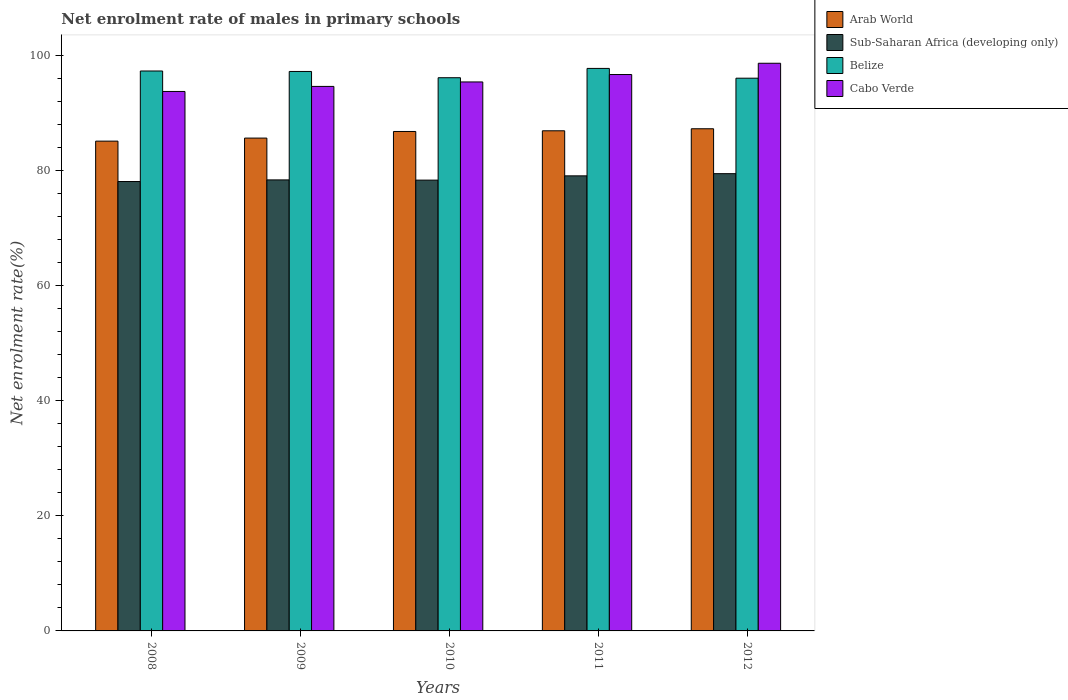Are the number of bars per tick equal to the number of legend labels?
Provide a succinct answer. Yes. Are the number of bars on each tick of the X-axis equal?
Offer a terse response. Yes. How many bars are there on the 4th tick from the left?
Offer a very short reply. 4. How many bars are there on the 5th tick from the right?
Provide a short and direct response. 4. What is the net enrolment rate of males in primary schools in Belize in 2010?
Ensure brevity in your answer.  96.17. Across all years, what is the maximum net enrolment rate of males in primary schools in Belize?
Ensure brevity in your answer.  97.79. Across all years, what is the minimum net enrolment rate of males in primary schools in Belize?
Make the answer very short. 96.09. What is the total net enrolment rate of males in primary schools in Cabo Verde in the graph?
Your response must be concise. 479.31. What is the difference between the net enrolment rate of males in primary schools in Sub-Saharan Africa (developing only) in 2008 and that in 2011?
Provide a succinct answer. -0.99. What is the difference between the net enrolment rate of males in primary schools in Cabo Verde in 2008 and the net enrolment rate of males in primary schools in Belize in 2009?
Offer a very short reply. -3.48. What is the average net enrolment rate of males in primary schools in Cabo Verde per year?
Offer a very short reply. 95.86. In the year 2012, what is the difference between the net enrolment rate of males in primary schools in Belize and net enrolment rate of males in primary schools in Sub-Saharan Africa (developing only)?
Your response must be concise. 16.6. What is the ratio of the net enrolment rate of males in primary schools in Belize in 2008 to that in 2010?
Provide a short and direct response. 1.01. Is the difference between the net enrolment rate of males in primary schools in Belize in 2009 and 2010 greater than the difference between the net enrolment rate of males in primary schools in Sub-Saharan Africa (developing only) in 2009 and 2010?
Give a very brief answer. Yes. What is the difference between the highest and the second highest net enrolment rate of males in primary schools in Arab World?
Your response must be concise. 0.35. What is the difference between the highest and the lowest net enrolment rate of males in primary schools in Belize?
Ensure brevity in your answer.  1.7. Is the sum of the net enrolment rate of males in primary schools in Cabo Verde in 2008 and 2011 greater than the maximum net enrolment rate of males in primary schools in Sub-Saharan Africa (developing only) across all years?
Provide a short and direct response. Yes. What does the 1st bar from the left in 2008 represents?
Offer a terse response. Arab World. What does the 4th bar from the right in 2012 represents?
Provide a short and direct response. Arab World. Is it the case that in every year, the sum of the net enrolment rate of males in primary schools in Belize and net enrolment rate of males in primary schools in Arab World is greater than the net enrolment rate of males in primary schools in Sub-Saharan Africa (developing only)?
Ensure brevity in your answer.  Yes. Are all the bars in the graph horizontal?
Your answer should be very brief. No. How many years are there in the graph?
Offer a very short reply. 5. What is the difference between two consecutive major ticks on the Y-axis?
Ensure brevity in your answer.  20. Does the graph contain any zero values?
Your answer should be compact. No. Does the graph contain grids?
Provide a succinct answer. No. How many legend labels are there?
Keep it short and to the point. 4. What is the title of the graph?
Provide a succinct answer. Net enrolment rate of males in primary schools. Does "Kazakhstan" appear as one of the legend labels in the graph?
Make the answer very short. No. What is the label or title of the Y-axis?
Your response must be concise. Net enrolment rate(%). What is the Net enrolment rate(%) in Arab World in 2008?
Offer a terse response. 85.15. What is the Net enrolment rate(%) in Sub-Saharan Africa (developing only) in 2008?
Provide a short and direct response. 78.13. What is the Net enrolment rate(%) in Belize in 2008?
Your response must be concise. 97.34. What is the Net enrolment rate(%) of Cabo Verde in 2008?
Ensure brevity in your answer.  93.79. What is the Net enrolment rate(%) of Arab World in 2009?
Offer a terse response. 85.68. What is the Net enrolment rate(%) in Sub-Saharan Africa (developing only) in 2009?
Give a very brief answer. 78.41. What is the Net enrolment rate(%) in Belize in 2009?
Provide a succinct answer. 97.26. What is the Net enrolment rate(%) in Cabo Verde in 2009?
Your answer should be very brief. 94.66. What is the Net enrolment rate(%) of Arab World in 2010?
Offer a terse response. 86.83. What is the Net enrolment rate(%) of Sub-Saharan Africa (developing only) in 2010?
Your answer should be very brief. 78.37. What is the Net enrolment rate(%) of Belize in 2010?
Your response must be concise. 96.17. What is the Net enrolment rate(%) of Cabo Verde in 2010?
Provide a short and direct response. 95.44. What is the Net enrolment rate(%) in Arab World in 2011?
Keep it short and to the point. 86.95. What is the Net enrolment rate(%) in Sub-Saharan Africa (developing only) in 2011?
Your response must be concise. 79.12. What is the Net enrolment rate(%) in Belize in 2011?
Your response must be concise. 97.79. What is the Net enrolment rate(%) of Cabo Verde in 2011?
Make the answer very short. 96.73. What is the Net enrolment rate(%) in Arab World in 2012?
Provide a short and direct response. 87.3. What is the Net enrolment rate(%) in Sub-Saharan Africa (developing only) in 2012?
Your answer should be very brief. 79.49. What is the Net enrolment rate(%) of Belize in 2012?
Offer a terse response. 96.09. What is the Net enrolment rate(%) in Cabo Verde in 2012?
Provide a short and direct response. 98.69. Across all years, what is the maximum Net enrolment rate(%) of Arab World?
Provide a short and direct response. 87.3. Across all years, what is the maximum Net enrolment rate(%) in Sub-Saharan Africa (developing only)?
Make the answer very short. 79.49. Across all years, what is the maximum Net enrolment rate(%) of Belize?
Your response must be concise. 97.79. Across all years, what is the maximum Net enrolment rate(%) of Cabo Verde?
Give a very brief answer. 98.69. Across all years, what is the minimum Net enrolment rate(%) of Arab World?
Make the answer very short. 85.15. Across all years, what is the minimum Net enrolment rate(%) in Sub-Saharan Africa (developing only)?
Make the answer very short. 78.13. Across all years, what is the minimum Net enrolment rate(%) in Belize?
Provide a succinct answer. 96.09. Across all years, what is the minimum Net enrolment rate(%) of Cabo Verde?
Provide a succinct answer. 93.79. What is the total Net enrolment rate(%) of Arab World in the graph?
Offer a terse response. 431.91. What is the total Net enrolment rate(%) of Sub-Saharan Africa (developing only) in the graph?
Offer a terse response. 393.52. What is the total Net enrolment rate(%) of Belize in the graph?
Offer a very short reply. 484.67. What is the total Net enrolment rate(%) in Cabo Verde in the graph?
Give a very brief answer. 479.31. What is the difference between the Net enrolment rate(%) of Arab World in 2008 and that in 2009?
Offer a very short reply. -0.53. What is the difference between the Net enrolment rate(%) of Sub-Saharan Africa (developing only) in 2008 and that in 2009?
Make the answer very short. -0.28. What is the difference between the Net enrolment rate(%) of Belize in 2008 and that in 2009?
Your answer should be compact. 0.08. What is the difference between the Net enrolment rate(%) of Cabo Verde in 2008 and that in 2009?
Ensure brevity in your answer.  -0.88. What is the difference between the Net enrolment rate(%) of Arab World in 2008 and that in 2010?
Your response must be concise. -1.68. What is the difference between the Net enrolment rate(%) in Sub-Saharan Africa (developing only) in 2008 and that in 2010?
Provide a succinct answer. -0.24. What is the difference between the Net enrolment rate(%) in Belize in 2008 and that in 2010?
Provide a succinct answer. 1.17. What is the difference between the Net enrolment rate(%) in Cabo Verde in 2008 and that in 2010?
Ensure brevity in your answer.  -1.66. What is the difference between the Net enrolment rate(%) in Arab World in 2008 and that in 2011?
Make the answer very short. -1.8. What is the difference between the Net enrolment rate(%) in Sub-Saharan Africa (developing only) in 2008 and that in 2011?
Offer a terse response. -0.99. What is the difference between the Net enrolment rate(%) of Belize in 2008 and that in 2011?
Your response must be concise. -0.45. What is the difference between the Net enrolment rate(%) of Cabo Verde in 2008 and that in 2011?
Your answer should be very brief. -2.94. What is the difference between the Net enrolment rate(%) in Arab World in 2008 and that in 2012?
Give a very brief answer. -2.15. What is the difference between the Net enrolment rate(%) in Sub-Saharan Africa (developing only) in 2008 and that in 2012?
Provide a succinct answer. -1.37. What is the difference between the Net enrolment rate(%) of Belize in 2008 and that in 2012?
Offer a terse response. 1.25. What is the difference between the Net enrolment rate(%) in Cabo Verde in 2008 and that in 2012?
Offer a very short reply. -4.9. What is the difference between the Net enrolment rate(%) in Arab World in 2009 and that in 2010?
Provide a short and direct response. -1.15. What is the difference between the Net enrolment rate(%) in Sub-Saharan Africa (developing only) in 2009 and that in 2010?
Your answer should be very brief. 0.04. What is the difference between the Net enrolment rate(%) of Belize in 2009 and that in 2010?
Ensure brevity in your answer.  1.09. What is the difference between the Net enrolment rate(%) of Cabo Verde in 2009 and that in 2010?
Your response must be concise. -0.78. What is the difference between the Net enrolment rate(%) in Arab World in 2009 and that in 2011?
Give a very brief answer. -1.27. What is the difference between the Net enrolment rate(%) of Sub-Saharan Africa (developing only) in 2009 and that in 2011?
Offer a terse response. -0.7. What is the difference between the Net enrolment rate(%) of Belize in 2009 and that in 2011?
Provide a succinct answer. -0.53. What is the difference between the Net enrolment rate(%) in Cabo Verde in 2009 and that in 2011?
Ensure brevity in your answer.  -2.07. What is the difference between the Net enrolment rate(%) in Arab World in 2009 and that in 2012?
Keep it short and to the point. -1.62. What is the difference between the Net enrolment rate(%) in Sub-Saharan Africa (developing only) in 2009 and that in 2012?
Keep it short and to the point. -1.08. What is the difference between the Net enrolment rate(%) in Belize in 2009 and that in 2012?
Make the answer very short. 1.17. What is the difference between the Net enrolment rate(%) in Cabo Verde in 2009 and that in 2012?
Keep it short and to the point. -4.02. What is the difference between the Net enrolment rate(%) in Arab World in 2010 and that in 2011?
Your answer should be very brief. -0.12. What is the difference between the Net enrolment rate(%) of Sub-Saharan Africa (developing only) in 2010 and that in 2011?
Your answer should be compact. -0.74. What is the difference between the Net enrolment rate(%) in Belize in 2010 and that in 2011?
Provide a short and direct response. -1.62. What is the difference between the Net enrolment rate(%) of Cabo Verde in 2010 and that in 2011?
Offer a very short reply. -1.29. What is the difference between the Net enrolment rate(%) in Arab World in 2010 and that in 2012?
Your response must be concise. -0.47. What is the difference between the Net enrolment rate(%) of Sub-Saharan Africa (developing only) in 2010 and that in 2012?
Make the answer very short. -1.12. What is the difference between the Net enrolment rate(%) in Belize in 2010 and that in 2012?
Make the answer very short. 0.08. What is the difference between the Net enrolment rate(%) in Cabo Verde in 2010 and that in 2012?
Provide a succinct answer. -3.25. What is the difference between the Net enrolment rate(%) of Arab World in 2011 and that in 2012?
Your response must be concise. -0.35. What is the difference between the Net enrolment rate(%) of Sub-Saharan Africa (developing only) in 2011 and that in 2012?
Your response must be concise. -0.38. What is the difference between the Net enrolment rate(%) of Belize in 2011 and that in 2012?
Your response must be concise. 1.7. What is the difference between the Net enrolment rate(%) of Cabo Verde in 2011 and that in 2012?
Offer a very short reply. -1.96. What is the difference between the Net enrolment rate(%) in Arab World in 2008 and the Net enrolment rate(%) in Sub-Saharan Africa (developing only) in 2009?
Give a very brief answer. 6.74. What is the difference between the Net enrolment rate(%) of Arab World in 2008 and the Net enrolment rate(%) of Belize in 2009?
Your answer should be compact. -12.11. What is the difference between the Net enrolment rate(%) of Arab World in 2008 and the Net enrolment rate(%) of Cabo Verde in 2009?
Your answer should be very brief. -9.51. What is the difference between the Net enrolment rate(%) of Sub-Saharan Africa (developing only) in 2008 and the Net enrolment rate(%) of Belize in 2009?
Provide a succinct answer. -19.14. What is the difference between the Net enrolment rate(%) in Sub-Saharan Africa (developing only) in 2008 and the Net enrolment rate(%) in Cabo Verde in 2009?
Your answer should be very brief. -16.54. What is the difference between the Net enrolment rate(%) in Belize in 2008 and the Net enrolment rate(%) in Cabo Verde in 2009?
Make the answer very short. 2.68. What is the difference between the Net enrolment rate(%) of Arab World in 2008 and the Net enrolment rate(%) of Sub-Saharan Africa (developing only) in 2010?
Provide a short and direct response. 6.78. What is the difference between the Net enrolment rate(%) in Arab World in 2008 and the Net enrolment rate(%) in Belize in 2010?
Ensure brevity in your answer.  -11.02. What is the difference between the Net enrolment rate(%) of Arab World in 2008 and the Net enrolment rate(%) of Cabo Verde in 2010?
Provide a succinct answer. -10.29. What is the difference between the Net enrolment rate(%) of Sub-Saharan Africa (developing only) in 2008 and the Net enrolment rate(%) of Belize in 2010?
Your answer should be very brief. -18.05. What is the difference between the Net enrolment rate(%) in Sub-Saharan Africa (developing only) in 2008 and the Net enrolment rate(%) in Cabo Verde in 2010?
Provide a short and direct response. -17.31. What is the difference between the Net enrolment rate(%) of Belize in 2008 and the Net enrolment rate(%) of Cabo Verde in 2010?
Ensure brevity in your answer.  1.9. What is the difference between the Net enrolment rate(%) of Arab World in 2008 and the Net enrolment rate(%) of Sub-Saharan Africa (developing only) in 2011?
Make the answer very short. 6.04. What is the difference between the Net enrolment rate(%) of Arab World in 2008 and the Net enrolment rate(%) of Belize in 2011?
Offer a terse response. -12.64. What is the difference between the Net enrolment rate(%) of Arab World in 2008 and the Net enrolment rate(%) of Cabo Verde in 2011?
Your answer should be compact. -11.58. What is the difference between the Net enrolment rate(%) in Sub-Saharan Africa (developing only) in 2008 and the Net enrolment rate(%) in Belize in 2011?
Give a very brief answer. -19.67. What is the difference between the Net enrolment rate(%) in Sub-Saharan Africa (developing only) in 2008 and the Net enrolment rate(%) in Cabo Verde in 2011?
Keep it short and to the point. -18.6. What is the difference between the Net enrolment rate(%) in Belize in 2008 and the Net enrolment rate(%) in Cabo Verde in 2011?
Keep it short and to the point. 0.61. What is the difference between the Net enrolment rate(%) of Arab World in 2008 and the Net enrolment rate(%) of Sub-Saharan Africa (developing only) in 2012?
Your answer should be compact. 5.66. What is the difference between the Net enrolment rate(%) of Arab World in 2008 and the Net enrolment rate(%) of Belize in 2012?
Ensure brevity in your answer.  -10.94. What is the difference between the Net enrolment rate(%) of Arab World in 2008 and the Net enrolment rate(%) of Cabo Verde in 2012?
Your answer should be compact. -13.54. What is the difference between the Net enrolment rate(%) in Sub-Saharan Africa (developing only) in 2008 and the Net enrolment rate(%) in Belize in 2012?
Offer a terse response. -17.97. What is the difference between the Net enrolment rate(%) in Sub-Saharan Africa (developing only) in 2008 and the Net enrolment rate(%) in Cabo Verde in 2012?
Your answer should be compact. -20.56. What is the difference between the Net enrolment rate(%) of Belize in 2008 and the Net enrolment rate(%) of Cabo Verde in 2012?
Your response must be concise. -1.35. What is the difference between the Net enrolment rate(%) in Arab World in 2009 and the Net enrolment rate(%) in Sub-Saharan Africa (developing only) in 2010?
Your answer should be compact. 7.31. What is the difference between the Net enrolment rate(%) of Arab World in 2009 and the Net enrolment rate(%) of Belize in 2010?
Provide a succinct answer. -10.49. What is the difference between the Net enrolment rate(%) of Arab World in 2009 and the Net enrolment rate(%) of Cabo Verde in 2010?
Offer a terse response. -9.76. What is the difference between the Net enrolment rate(%) of Sub-Saharan Africa (developing only) in 2009 and the Net enrolment rate(%) of Belize in 2010?
Your response must be concise. -17.76. What is the difference between the Net enrolment rate(%) of Sub-Saharan Africa (developing only) in 2009 and the Net enrolment rate(%) of Cabo Verde in 2010?
Offer a terse response. -17.03. What is the difference between the Net enrolment rate(%) in Belize in 2009 and the Net enrolment rate(%) in Cabo Verde in 2010?
Make the answer very short. 1.82. What is the difference between the Net enrolment rate(%) in Arab World in 2009 and the Net enrolment rate(%) in Sub-Saharan Africa (developing only) in 2011?
Provide a succinct answer. 6.57. What is the difference between the Net enrolment rate(%) in Arab World in 2009 and the Net enrolment rate(%) in Belize in 2011?
Your answer should be compact. -12.11. What is the difference between the Net enrolment rate(%) in Arab World in 2009 and the Net enrolment rate(%) in Cabo Verde in 2011?
Offer a very short reply. -11.05. What is the difference between the Net enrolment rate(%) of Sub-Saharan Africa (developing only) in 2009 and the Net enrolment rate(%) of Belize in 2011?
Keep it short and to the point. -19.38. What is the difference between the Net enrolment rate(%) in Sub-Saharan Africa (developing only) in 2009 and the Net enrolment rate(%) in Cabo Verde in 2011?
Provide a short and direct response. -18.32. What is the difference between the Net enrolment rate(%) in Belize in 2009 and the Net enrolment rate(%) in Cabo Verde in 2011?
Offer a terse response. 0.53. What is the difference between the Net enrolment rate(%) in Arab World in 2009 and the Net enrolment rate(%) in Sub-Saharan Africa (developing only) in 2012?
Keep it short and to the point. 6.19. What is the difference between the Net enrolment rate(%) of Arab World in 2009 and the Net enrolment rate(%) of Belize in 2012?
Provide a succinct answer. -10.41. What is the difference between the Net enrolment rate(%) in Arab World in 2009 and the Net enrolment rate(%) in Cabo Verde in 2012?
Offer a terse response. -13.01. What is the difference between the Net enrolment rate(%) in Sub-Saharan Africa (developing only) in 2009 and the Net enrolment rate(%) in Belize in 2012?
Keep it short and to the point. -17.68. What is the difference between the Net enrolment rate(%) of Sub-Saharan Africa (developing only) in 2009 and the Net enrolment rate(%) of Cabo Verde in 2012?
Provide a short and direct response. -20.28. What is the difference between the Net enrolment rate(%) in Belize in 2009 and the Net enrolment rate(%) in Cabo Verde in 2012?
Your answer should be very brief. -1.43. What is the difference between the Net enrolment rate(%) in Arab World in 2010 and the Net enrolment rate(%) in Sub-Saharan Africa (developing only) in 2011?
Make the answer very short. 7.71. What is the difference between the Net enrolment rate(%) of Arab World in 2010 and the Net enrolment rate(%) of Belize in 2011?
Your answer should be compact. -10.96. What is the difference between the Net enrolment rate(%) of Arab World in 2010 and the Net enrolment rate(%) of Cabo Verde in 2011?
Ensure brevity in your answer.  -9.9. What is the difference between the Net enrolment rate(%) of Sub-Saharan Africa (developing only) in 2010 and the Net enrolment rate(%) of Belize in 2011?
Keep it short and to the point. -19.42. What is the difference between the Net enrolment rate(%) of Sub-Saharan Africa (developing only) in 2010 and the Net enrolment rate(%) of Cabo Verde in 2011?
Your response must be concise. -18.36. What is the difference between the Net enrolment rate(%) of Belize in 2010 and the Net enrolment rate(%) of Cabo Verde in 2011?
Your response must be concise. -0.56. What is the difference between the Net enrolment rate(%) in Arab World in 2010 and the Net enrolment rate(%) in Sub-Saharan Africa (developing only) in 2012?
Keep it short and to the point. 7.34. What is the difference between the Net enrolment rate(%) in Arab World in 2010 and the Net enrolment rate(%) in Belize in 2012?
Offer a very short reply. -9.26. What is the difference between the Net enrolment rate(%) in Arab World in 2010 and the Net enrolment rate(%) in Cabo Verde in 2012?
Ensure brevity in your answer.  -11.86. What is the difference between the Net enrolment rate(%) in Sub-Saharan Africa (developing only) in 2010 and the Net enrolment rate(%) in Belize in 2012?
Your answer should be compact. -17.72. What is the difference between the Net enrolment rate(%) of Sub-Saharan Africa (developing only) in 2010 and the Net enrolment rate(%) of Cabo Verde in 2012?
Make the answer very short. -20.32. What is the difference between the Net enrolment rate(%) in Belize in 2010 and the Net enrolment rate(%) in Cabo Verde in 2012?
Your response must be concise. -2.52. What is the difference between the Net enrolment rate(%) of Arab World in 2011 and the Net enrolment rate(%) of Sub-Saharan Africa (developing only) in 2012?
Your response must be concise. 7.46. What is the difference between the Net enrolment rate(%) in Arab World in 2011 and the Net enrolment rate(%) in Belize in 2012?
Your response must be concise. -9.14. What is the difference between the Net enrolment rate(%) in Arab World in 2011 and the Net enrolment rate(%) in Cabo Verde in 2012?
Give a very brief answer. -11.74. What is the difference between the Net enrolment rate(%) of Sub-Saharan Africa (developing only) in 2011 and the Net enrolment rate(%) of Belize in 2012?
Provide a short and direct response. -16.98. What is the difference between the Net enrolment rate(%) in Sub-Saharan Africa (developing only) in 2011 and the Net enrolment rate(%) in Cabo Verde in 2012?
Provide a short and direct response. -19.57. What is the difference between the Net enrolment rate(%) of Belize in 2011 and the Net enrolment rate(%) of Cabo Verde in 2012?
Provide a short and direct response. -0.9. What is the average Net enrolment rate(%) of Arab World per year?
Provide a short and direct response. 86.38. What is the average Net enrolment rate(%) of Sub-Saharan Africa (developing only) per year?
Make the answer very short. 78.7. What is the average Net enrolment rate(%) in Belize per year?
Offer a very short reply. 96.93. What is the average Net enrolment rate(%) in Cabo Verde per year?
Make the answer very short. 95.86. In the year 2008, what is the difference between the Net enrolment rate(%) in Arab World and Net enrolment rate(%) in Sub-Saharan Africa (developing only)?
Offer a very short reply. 7.02. In the year 2008, what is the difference between the Net enrolment rate(%) in Arab World and Net enrolment rate(%) in Belize?
Make the answer very short. -12.19. In the year 2008, what is the difference between the Net enrolment rate(%) in Arab World and Net enrolment rate(%) in Cabo Verde?
Provide a short and direct response. -8.63. In the year 2008, what is the difference between the Net enrolment rate(%) of Sub-Saharan Africa (developing only) and Net enrolment rate(%) of Belize?
Provide a succinct answer. -19.22. In the year 2008, what is the difference between the Net enrolment rate(%) in Sub-Saharan Africa (developing only) and Net enrolment rate(%) in Cabo Verde?
Offer a very short reply. -15.66. In the year 2008, what is the difference between the Net enrolment rate(%) of Belize and Net enrolment rate(%) of Cabo Verde?
Keep it short and to the point. 3.56. In the year 2009, what is the difference between the Net enrolment rate(%) of Arab World and Net enrolment rate(%) of Sub-Saharan Africa (developing only)?
Your answer should be compact. 7.27. In the year 2009, what is the difference between the Net enrolment rate(%) in Arab World and Net enrolment rate(%) in Belize?
Offer a terse response. -11.58. In the year 2009, what is the difference between the Net enrolment rate(%) in Arab World and Net enrolment rate(%) in Cabo Verde?
Provide a succinct answer. -8.98. In the year 2009, what is the difference between the Net enrolment rate(%) in Sub-Saharan Africa (developing only) and Net enrolment rate(%) in Belize?
Make the answer very short. -18.85. In the year 2009, what is the difference between the Net enrolment rate(%) of Sub-Saharan Africa (developing only) and Net enrolment rate(%) of Cabo Verde?
Make the answer very short. -16.25. In the year 2009, what is the difference between the Net enrolment rate(%) in Belize and Net enrolment rate(%) in Cabo Verde?
Your response must be concise. 2.6. In the year 2010, what is the difference between the Net enrolment rate(%) in Arab World and Net enrolment rate(%) in Sub-Saharan Africa (developing only)?
Keep it short and to the point. 8.46. In the year 2010, what is the difference between the Net enrolment rate(%) in Arab World and Net enrolment rate(%) in Belize?
Provide a short and direct response. -9.34. In the year 2010, what is the difference between the Net enrolment rate(%) in Arab World and Net enrolment rate(%) in Cabo Verde?
Provide a succinct answer. -8.61. In the year 2010, what is the difference between the Net enrolment rate(%) in Sub-Saharan Africa (developing only) and Net enrolment rate(%) in Belize?
Your answer should be very brief. -17.8. In the year 2010, what is the difference between the Net enrolment rate(%) of Sub-Saharan Africa (developing only) and Net enrolment rate(%) of Cabo Verde?
Offer a very short reply. -17.07. In the year 2010, what is the difference between the Net enrolment rate(%) of Belize and Net enrolment rate(%) of Cabo Verde?
Ensure brevity in your answer.  0.73. In the year 2011, what is the difference between the Net enrolment rate(%) in Arab World and Net enrolment rate(%) in Sub-Saharan Africa (developing only)?
Give a very brief answer. 7.83. In the year 2011, what is the difference between the Net enrolment rate(%) in Arab World and Net enrolment rate(%) in Belize?
Ensure brevity in your answer.  -10.84. In the year 2011, what is the difference between the Net enrolment rate(%) in Arab World and Net enrolment rate(%) in Cabo Verde?
Keep it short and to the point. -9.78. In the year 2011, what is the difference between the Net enrolment rate(%) in Sub-Saharan Africa (developing only) and Net enrolment rate(%) in Belize?
Your answer should be compact. -18.68. In the year 2011, what is the difference between the Net enrolment rate(%) in Sub-Saharan Africa (developing only) and Net enrolment rate(%) in Cabo Verde?
Offer a very short reply. -17.61. In the year 2011, what is the difference between the Net enrolment rate(%) in Belize and Net enrolment rate(%) in Cabo Verde?
Your answer should be very brief. 1.06. In the year 2012, what is the difference between the Net enrolment rate(%) in Arab World and Net enrolment rate(%) in Sub-Saharan Africa (developing only)?
Keep it short and to the point. 7.81. In the year 2012, what is the difference between the Net enrolment rate(%) of Arab World and Net enrolment rate(%) of Belize?
Make the answer very short. -8.79. In the year 2012, what is the difference between the Net enrolment rate(%) of Arab World and Net enrolment rate(%) of Cabo Verde?
Your answer should be compact. -11.39. In the year 2012, what is the difference between the Net enrolment rate(%) in Sub-Saharan Africa (developing only) and Net enrolment rate(%) in Belize?
Keep it short and to the point. -16.6. In the year 2012, what is the difference between the Net enrolment rate(%) of Sub-Saharan Africa (developing only) and Net enrolment rate(%) of Cabo Verde?
Ensure brevity in your answer.  -19.2. In the year 2012, what is the difference between the Net enrolment rate(%) in Belize and Net enrolment rate(%) in Cabo Verde?
Ensure brevity in your answer.  -2.6. What is the ratio of the Net enrolment rate(%) of Cabo Verde in 2008 to that in 2009?
Give a very brief answer. 0.99. What is the ratio of the Net enrolment rate(%) of Arab World in 2008 to that in 2010?
Your response must be concise. 0.98. What is the ratio of the Net enrolment rate(%) of Belize in 2008 to that in 2010?
Your answer should be compact. 1.01. What is the ratio of the Net enrolment rate(%) of Cabo Verde in 2008 to that in 2010?
Keep it short and to the point. 0.98. What is the ratio of the Net enrolment rate(%) of Arab World in 2008 to that in 2011?
Make the answer very short. 0.98. What is the ratio of the Net enrolment rate(%) in Sub-Saharan Africa (developing only) in 2008 to that in 2011?
Your answer should be very brief. 0.99. What is the ratio of the Net enrolment rate(%) in Cabo Verde in 2008 to that in 2011?
Make the answer very short. 0.97. What is the ratio of the Net enrolment rate(%) in Arab World in 2008 to that in 2012?
Your answer should be very brief. 0.98. What is the ratio of the Net enrolment rate(%) of Sub-Saharan Africa (developing only) in 2008 to that in 2012?
Offer a very short reply. 0.98. What is the ratio of the Net enrolment rate(%) of Cabo Verde in 2008 to that in 2012?
Your answer should be compact. 0.95. What is the ratio of the Net enrolment rate(%) in Arab World in 2009 to that in 2010?
Your answer should be very brief. 0.99. What is the ratio of the Net enrolment rate(%) in Belize in 2009 to that in 2010?
Your response must be concise. 1.01. What is the ratio of the Net enrolment rate(%) in Cabo Verde in 2009 to that in 2010?
Keep it short and to the point. 0.99. What is the ratio of the Net enrolment rate(%) of Arab World in 2009 to that in 2011?
Give a very brief answer. 0.99. What is the ratio of the Net enrolment rate(%) of Sub-Saharan Africa (developing only) in 2009 to that in 2011?
Your response must be concise. 0.99. What is the ratio of the Net enrolment rate(%) of Belize in 2009 to that in 2011?
Keep it short and to the point. 0.99. What is the ratio of the Net enrolment rate(%) of Cabo Verde in 2009 to that in 2011?
Provide a succinct answer. 0.98. What is the ratio of the Net enrolment rate(%) in Arab World in 2009 to that in 2012?
Your response must be concise. 0.98. What is the ratio of the Net enrolment rate(%) in Sub-Saharan Africa (developing only) in 2009 to that in 2012?
Your answer should be very brief. 0.99. What is the ratio of the Net enrolment rate(%) in Belize in 2009 to that in 2012?
Your response must be concise. 1.01. What is the ratio of the Net enrolment rate(%) in Cabo Verde in 2009 to that in 2012?
Ensure brevity in your answer.  0.96. What is the ratio of the Net enrolment rate(%) in Sub-Saharan Africa (developing only) in 2010 to that in 2011?
Provide a succinct answer. 0.99. What is the ratio of the Net enrolment rate(%) of Belize in 2010 to that in 2011?
Provide a short and direct response. 0.98. What is the ratio of the Net enrolment rate(%) of Cabo Verde in 2010 to that in 2011?
Your answer should be compact. 0.99. What is the ratio of the Net enrolment rate(%) of Sub-Saharan Africa (developing only) in 2010 to that in 2012?
Make the answer very short. 0.99. What is the ratio of the Net enrolment rate(%) in Belize in 2010 to that in 2012?
Your response must be concise. 1. What is the ratio of the Net enrolment rate(%) of Cabo Verde in 2010 to that in 2012?
Keep it short and to the point. 0.97. What is the ratio of the Net enrolment rate(%) of Arab World in 2011 to that in 2012?
Offer a very short reply. 1. What is the ratio of the Net enrolment rate(%) of Belize in 2011 to that in 2012?
Keep it short and to the point. 1.02. What is the ratio of the Net enrolment rate(%) of Cabo Verde in 2011 to that in 2012?
Keep it short and to the point. 0.98. What is the difference between the highest and the second highest Net enrolment rate(%) in Arab World?
Offer a very short reply. 0.35. What is the difference between the highest and the second highest Net enrolment rate(%) in Sub-Saharan Africa (developing only)?
Keep it short and to the point. 0.38. What is the difference between the highest and the second highest Net enrolment rate(%) in Belize?
Provide a short and direct response. 0.45. What is the difference between the highest and the second highest Net enrolment rate(%) in Cabo Verde?
Keep it short and to the point. 1.96. What is the difference between the highest and the lowest Net enrolment rate(%) of Arab World?
Your answer should be compact. 2.15. What is the difference between the highest and the lowest Net enrolment rate(%) of Sub-Saharan Africa (developing only)?
Offer a terse response. 1.37. What is the difference between the highest and the lowest Net enrolment rate(%) of Belize?
Your response must be concise. 1.7. What is the difference between the highest and the lowest Net enrolment rate(%) in Cabo Verde?
Your answer should be compact. 4.9. 